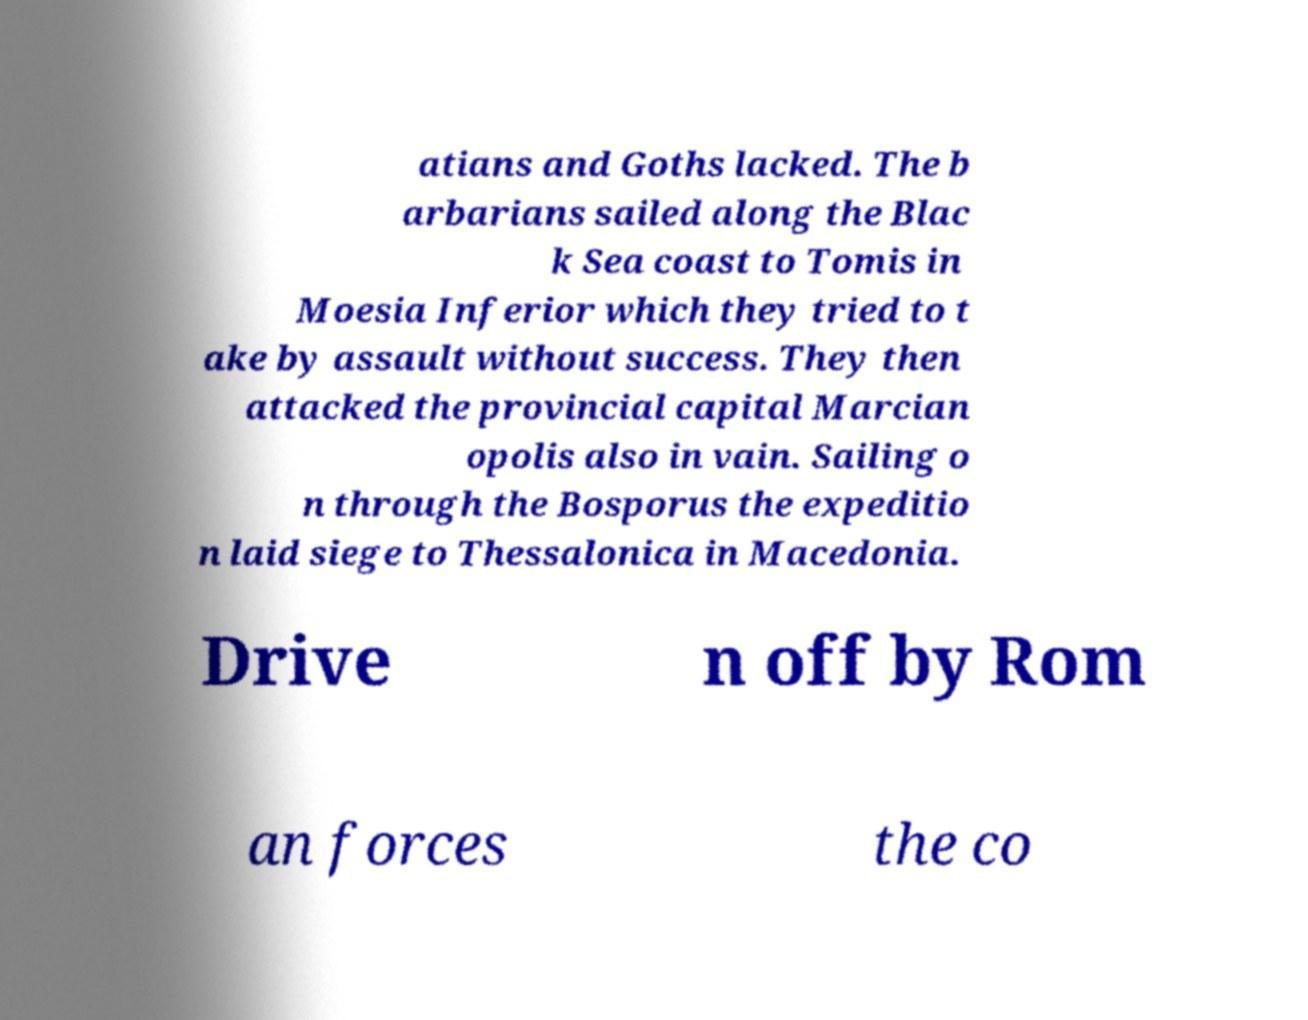Please identify and transcribe the text found in this image. atians and Goths lacked. The b arbarians sailed along the Blac k Sea coast to Tomis in Moesia Inferior which they tried to t ake by assault without success. They then attacked the provincial capital Marcian opolis also in vain. Sailing o n through the Bosporus the expeditio n laid siege to Thessalonica in Macedonia. Drive n off by Rom an forces the co 